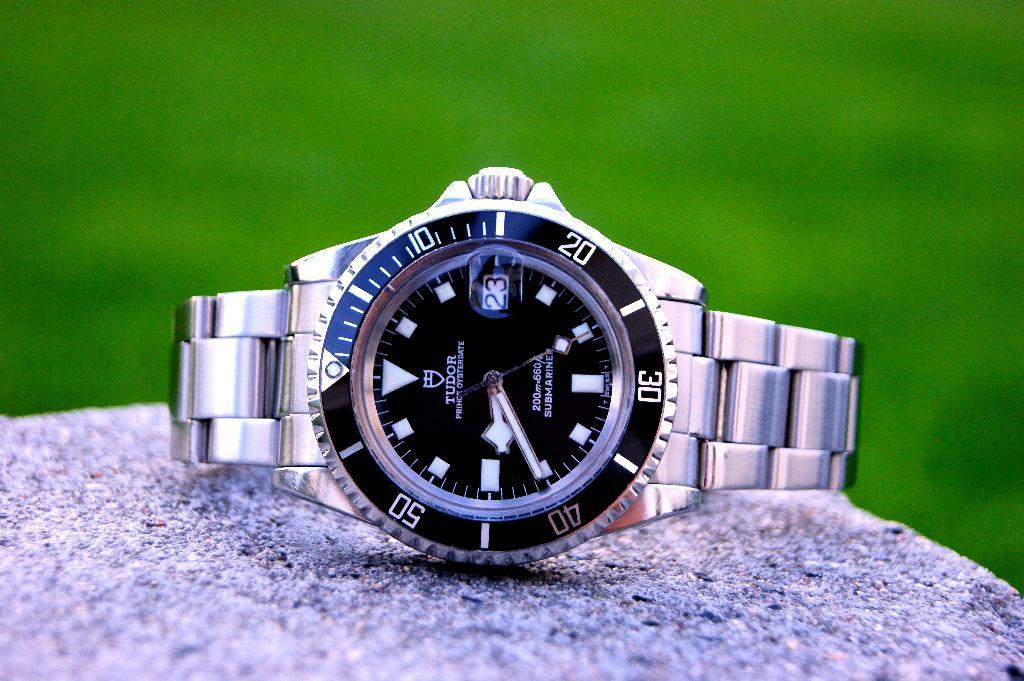<image>
Give a short and clear explanation of the subsequent image. A Rolex silver watch with a black face and date of the 23rd. 